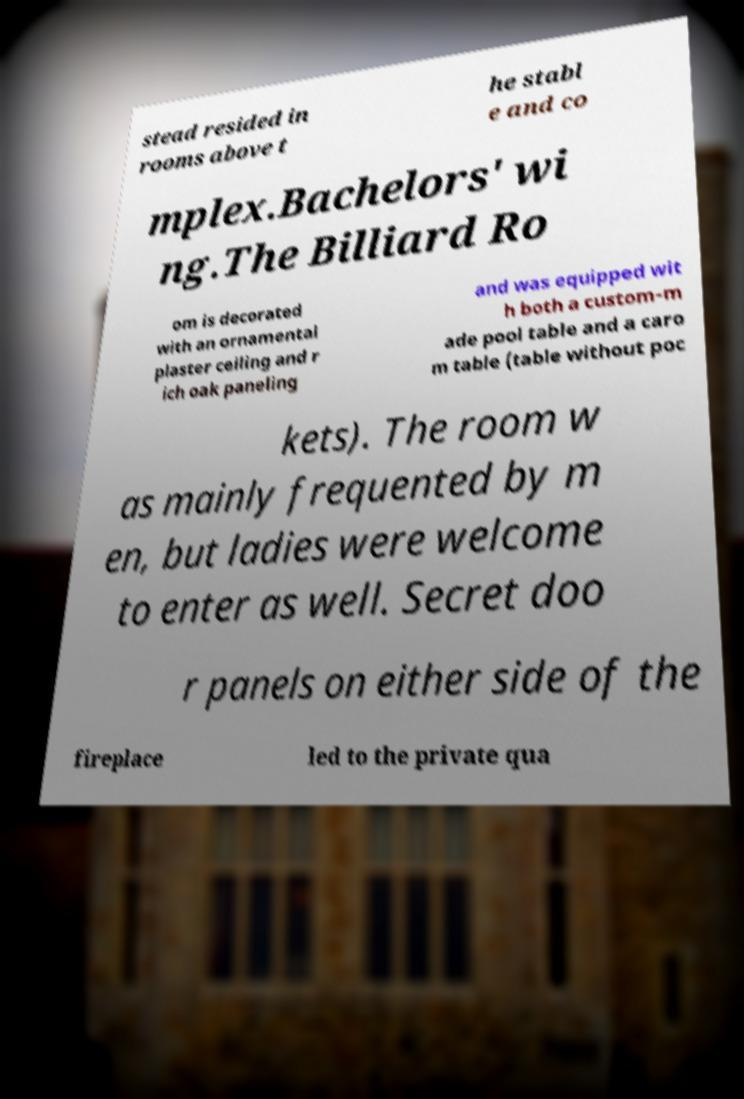Could you assist in decoding the text presented in this image and type it out clearly? stead resided in rooms above t he stabl e and co mplex.Bachelors' wi ng.The Billiard Ro om is decorated with an ornamental plaster ceiling and r ich oak paneling and was equipped wit h both a custom-m ade pool table and a caro m table (table without poc kets). The room w as mainly frequented by m en, but ladies were welcome to enter as well. Secret doo r panels on either side of the fireplace led to the private qua 